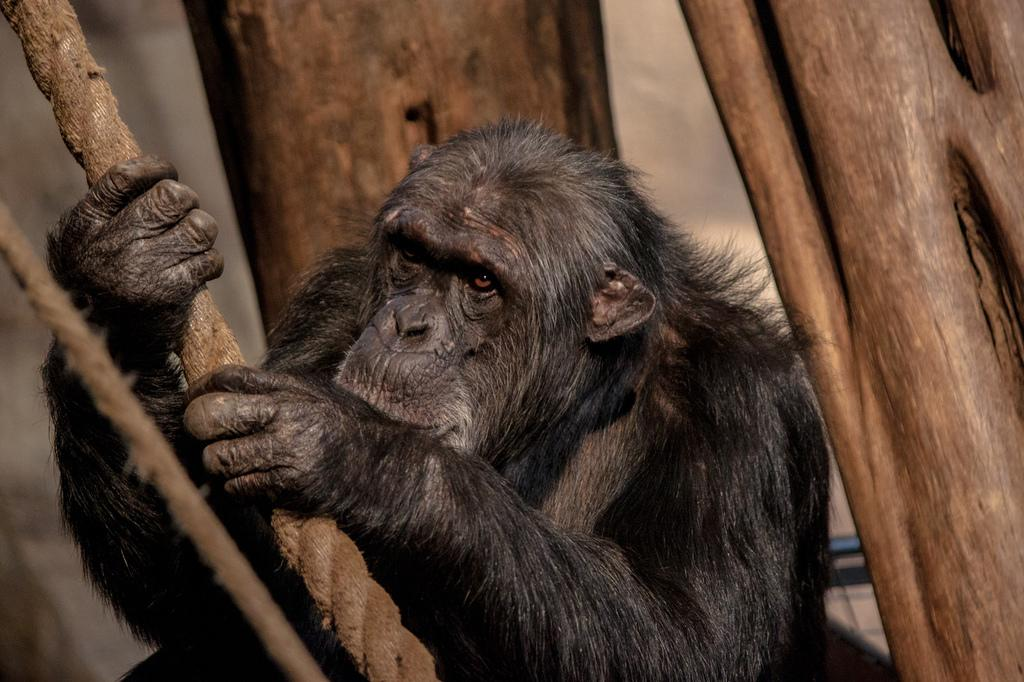What animal is present in the image? There is a chimpanzee in the image. What is the chimpanzee holding in the image? The chimpanzee is holding a rope. What can be seen in the background of the image? There are trees visible in the background of the image. Where are the ropes located in the image? There are ropes on the left side of the image. What type of disease is the chimpanzee suffering from in the image? There is no indication in the image that the chimpanzee is suffering from any disease. 